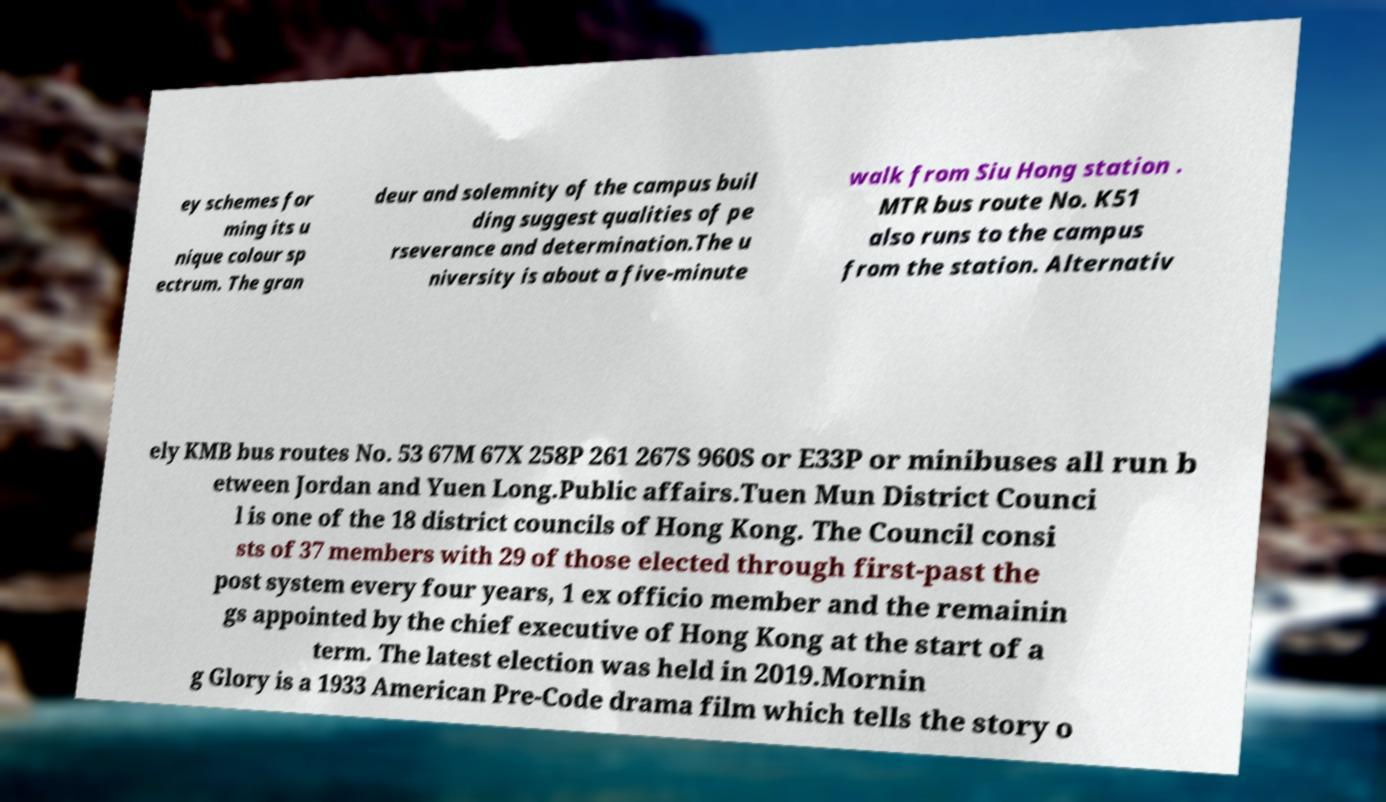For documentation purposes, I need the text within this image transcribed. Could you provide that? ey schemes for ming its u nique colour sp ectrum. The gran deur and solemnity of the campus buil ding suggest qualities of pe rseverance and determination.The u niversity is about a five-minute walk from Siu Hong station . MTR bus route No. K51 also runs to the campus from the station. Alternativ ely KMB bus routes No. 53 67M 67X 258P 261 267S 960S or E33P or minibuses all run b etween Jordan and Yuen Long.Public affairs.Tuen Mun District Counci l is one of the 18 district councils of Hong Kong. The Council consi sts of 37 members with 29 of those elected through first-past the post system every four years, 1 ex officio member and the remainin gs appointed by the chief executive of Hong Kong at the start of a term. The latest election was held in 2019.Mornin g Glory is a 1933 American Pre-Code drama film which tells the story o 